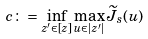Convert formula to latex. <formula><loc_0><loc_0><loc_500><loc_500>c \colon = \inf _ { z ^ { \prime } \in [ z ] } \max _ { u \in | z ^ { \prime } | } \widetilde { J } _ { s } ( u )</formula> 